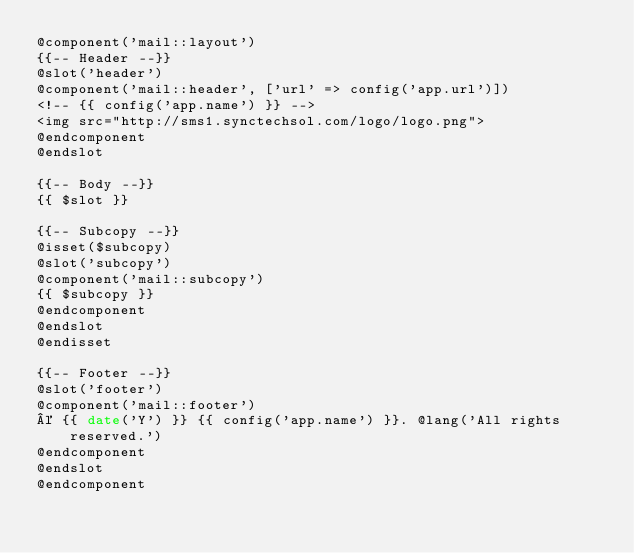Convert code to text. <code><loc_0><loc_0><loc_500><loc_500><_PHP_>@component('mail::layout')
{{-- Header --}}
@slot('header')
@component('mail::header', ['url' => config('app.url')])
<!-- {{ config('app.name') }} -->
<img src="http://sms1.synctechsol.com/logo/logo.png">
@endcomponent
@endslot

{{-- Body --}}
{{ $slot }}

{{-- Subcopy --}}
@isset($subcopy)
@slot('subcopy')
@component('mail::subcopy')
{{ $subcopy }}
@endcomponent
@endslot
@endisset

{{-- Footer --}}
@slot('footer')
@component('mail::footer')
© {{ date('Y') }} {{ config('app.name') }}. @lang('All rights reserved.')
@endcomponent
@endslot
@endcomponent
</code> 